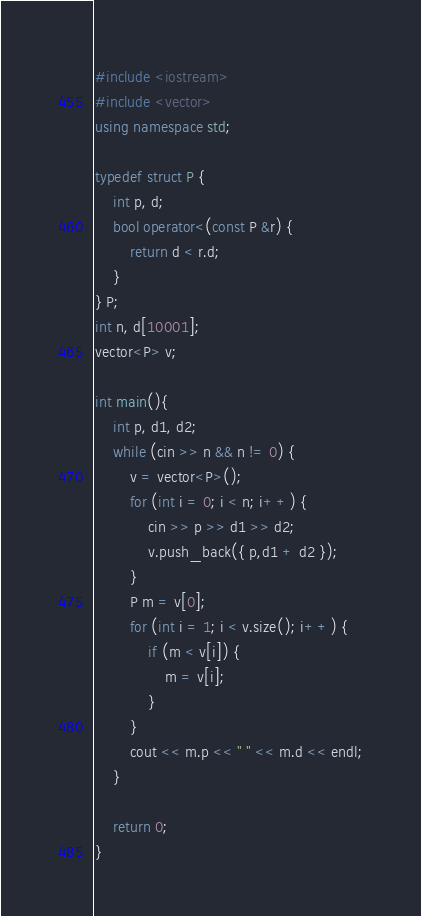Convert code to text. <code><loc_0><loc_0><loc_500><loc_500><_C++_>#include <iostream>
#include <vector>
using namespace std;

typedef struct P {
	int p, d;
	bool operator<(const P &r) {
		return d < r.d;
	}
} P;
int n, d[10001];
vector<P> v;

int main(){
	int p, d1, d2;
	while (cin >> n && n != 0) {
		v = vector<P>();
		for (int i = 0; i < n; i++) {
			cin >> p >> d1 >> d2;
			v.push_back({ p,d1 + d2 });
		}
		P m = v[0];
		for (int i = 1; i < v.size(); i++) {
			if (m < v[i]) {
				m = v[i];
			}
		}
		cout << m.p << " " << m.d << endl;
	}

	return 0;
}</code> 